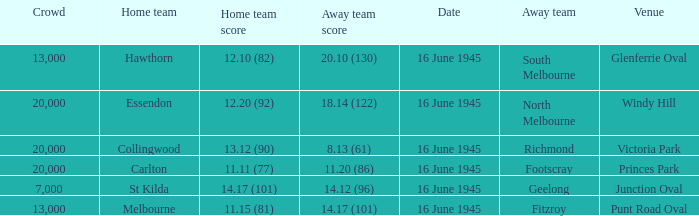What was the Home team score for the team that played South Melbourne? 12.10 (82). 